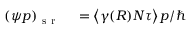<formula> <loc_0><loc_0><loc_500><loc_500>\begin{array} { r l } { ( \psi p ) _ { s r } } & = \left \langle \gamma ( R ) N \tau \right \rangle p / } \end{array}</formula> 